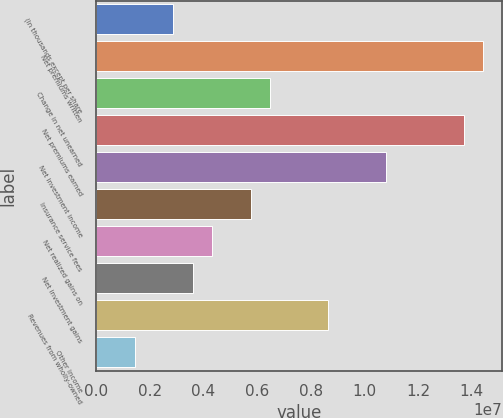Convert chart to OTSL. <chart><loc_0><loc_0><loc_500><loc_500><bar_chart><fcel>(In thousands except per share<fcel>Net premiums written<fcel>Change in net unearned<fcel>Net premiums earned<fcel>Net investment income<fcel>Insurance service fees<fcel>Net realized gains on<fcel>Net investment gains<fcel>Revenues from wholly-owned<fcel>Other income<nl><fcel>2.88259e+06<fcel>1.44129e+07<fcel>6.48581e+06<fcel>1.36923e+07<fcel>1.08097e+07<fcel>5.76517e+06<fcel>4.32388e+06<fcel>3.60323e+06<fcel>8.64775e+06<fcel>1.44129e+06<nl></chart> 